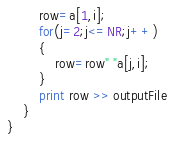<code> <loc_0><loc_0><loc_500><loc_500><_Awk_>        row=a[1,i];
        for(j=2;j<=NR;j++)
        {
            row=row" "a[j,i];
        }
        print row >> outputFile
    }
}
</code> 